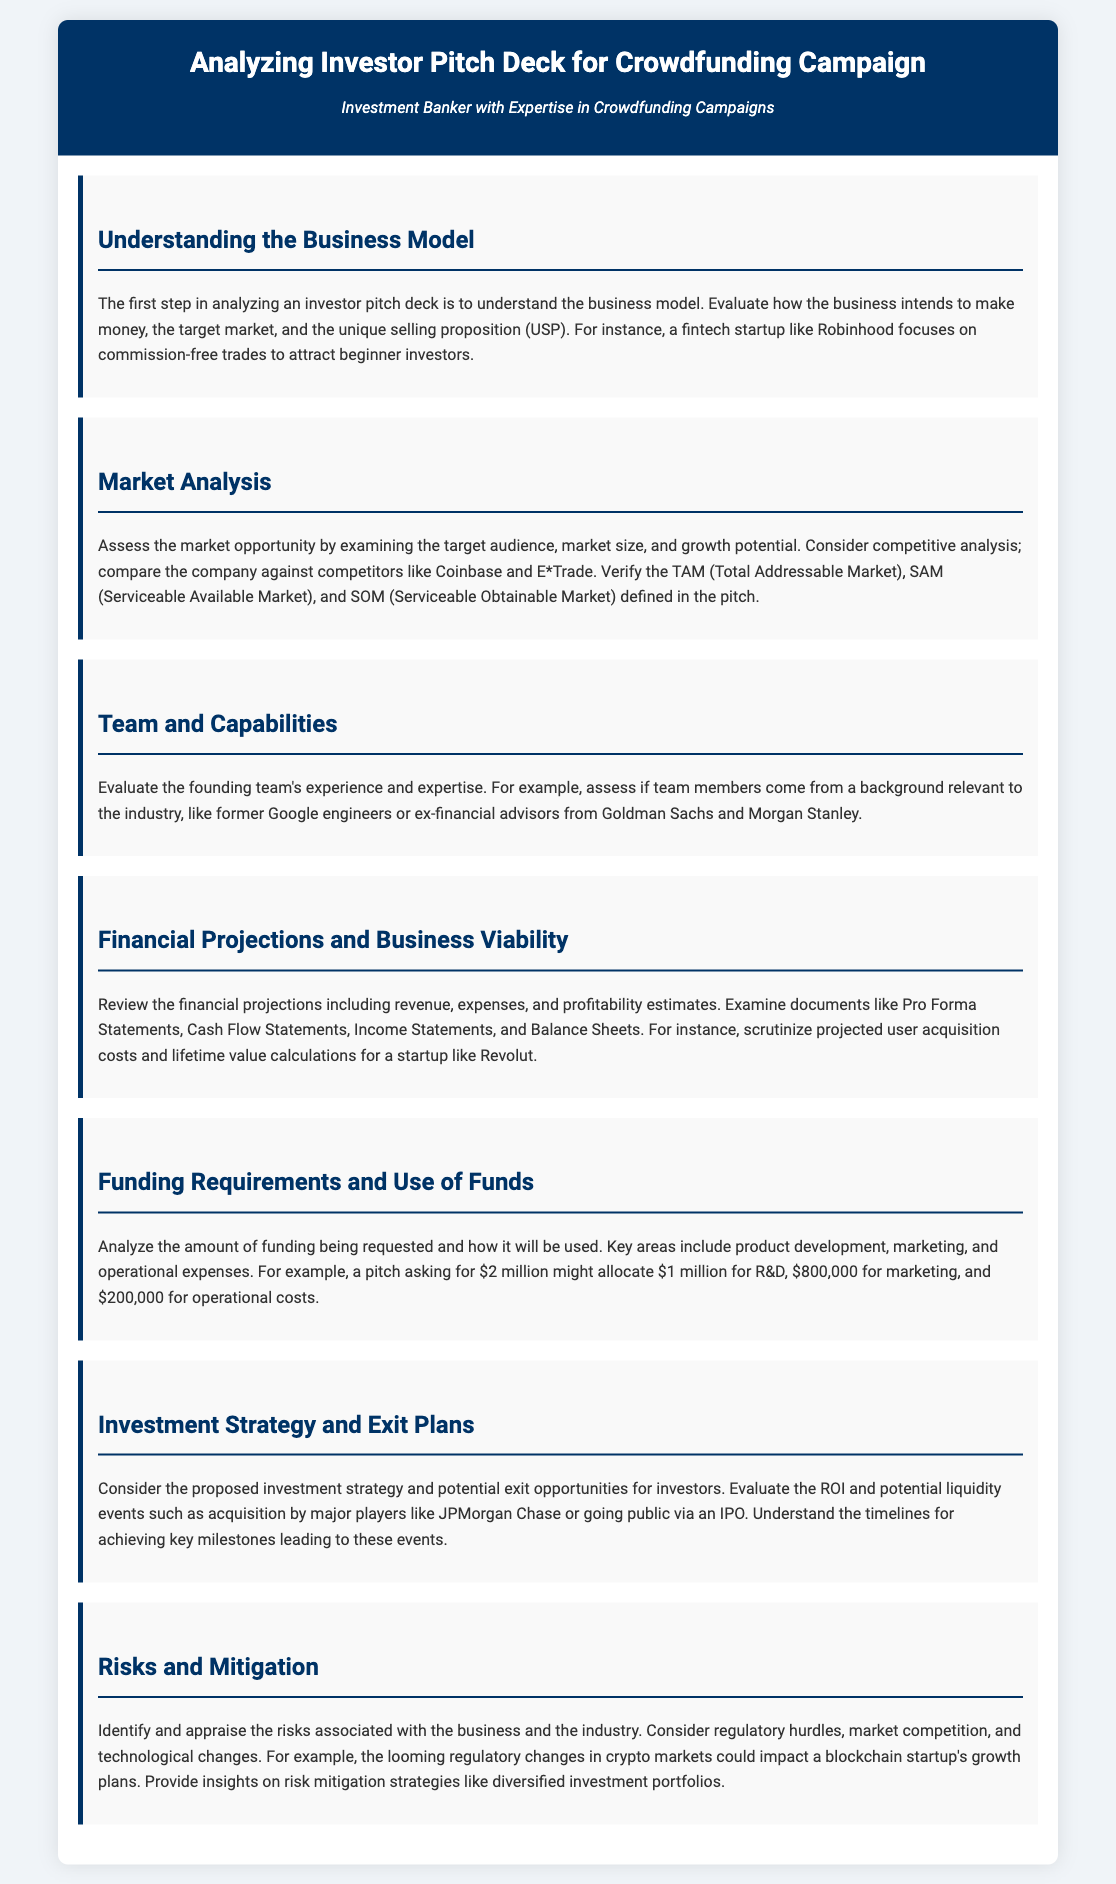what is the first step in analyzing an investor pitch deck? The first step is to understand the business model.
Answer: understanding the business model which startup is used as an example for financial projections? The example used for financial projections is Revolut.
Answer: Revolut what is the funding request example amount mentioned in the document? The document mentions a funding request example amount of $2 million.
Answer: $2 million what does TAM stand for in market analysis? TAM stands for Total Addressable Market.
Answer: Total Addressable Market who should be evaluated in the team and capabilities section? The founding team members should be evaluated for experience and expertise.
Answer: founding team members what are the key areas analyzed for use of funds? The key areas include product development, marketing, and operational expenses.
Answer: product development, marketing, operational expenses which major player is mentioned as a potential acquirer in the investment strategy? JPMorgan Chase is mentioned as a potential acquirer.
Answer: JPMorgan Chase what type of risks are identified in the risks and mitigation section? Regulatory hurdles, market competition, and technological changes are identified as risks.
Answer: regulatory hurdles, market competition, technological changes 